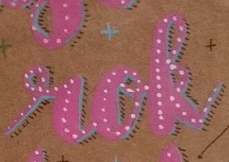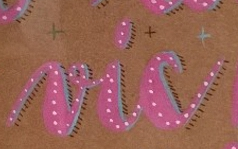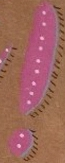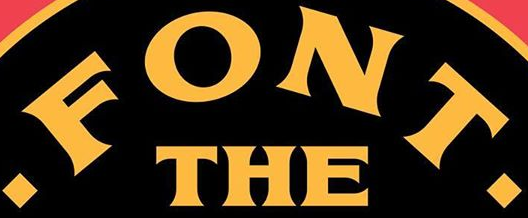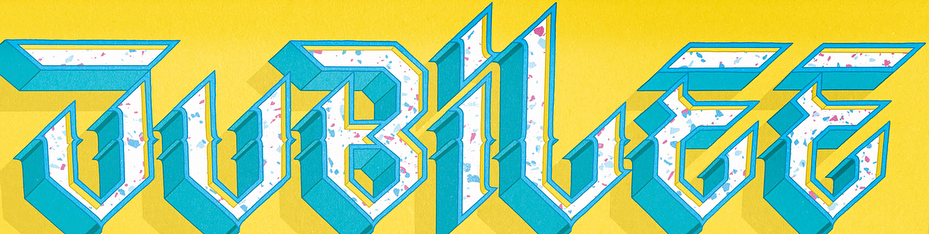What words are shown in these images in order, separated by a semicolon? rok; vic; !; .FONT.; JUBiLEE 